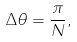Convert formula to latex. <formula><loc_0><loc_0><loc_500><loc_500>\Delta \theta = \frac { \pi } { N } ,</formula> 